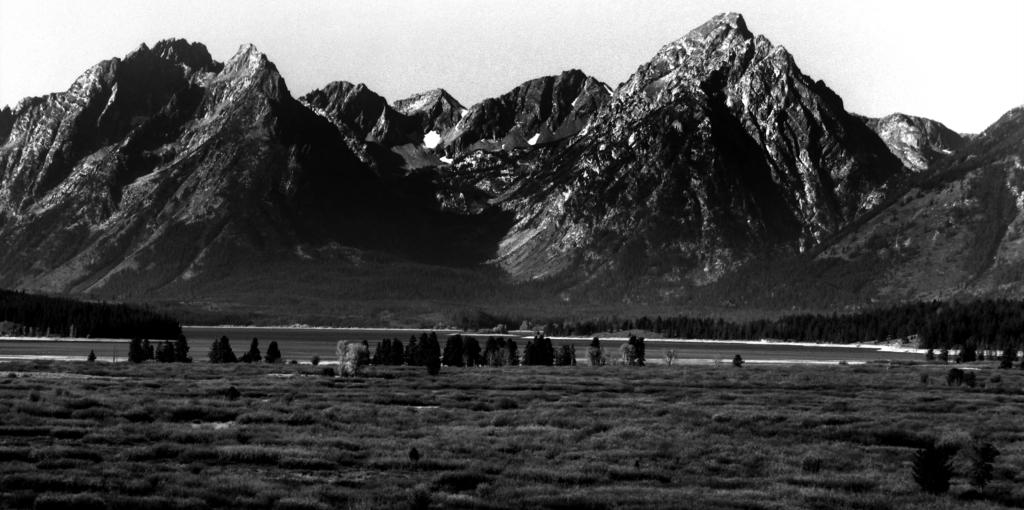What is the color scheme of the image? The image is black and white. What type of natural feature can be seen in the image? There is a water body in the image. What type of vegetation is present in the image? There is a group of trees and grass in the image. What can be seen in the background of the image? There are ice hills visible in the background. How would you describe the sky in the image? The sky appears cloudy in the image. How many boys are holding a knot in the image? There are no boys or knots present in the image. What type of organization is depicted in the image? There is no organization depicted in the image; it features natural elements such as a water body, trees, grass, ice hills, and a cloudy sky. 